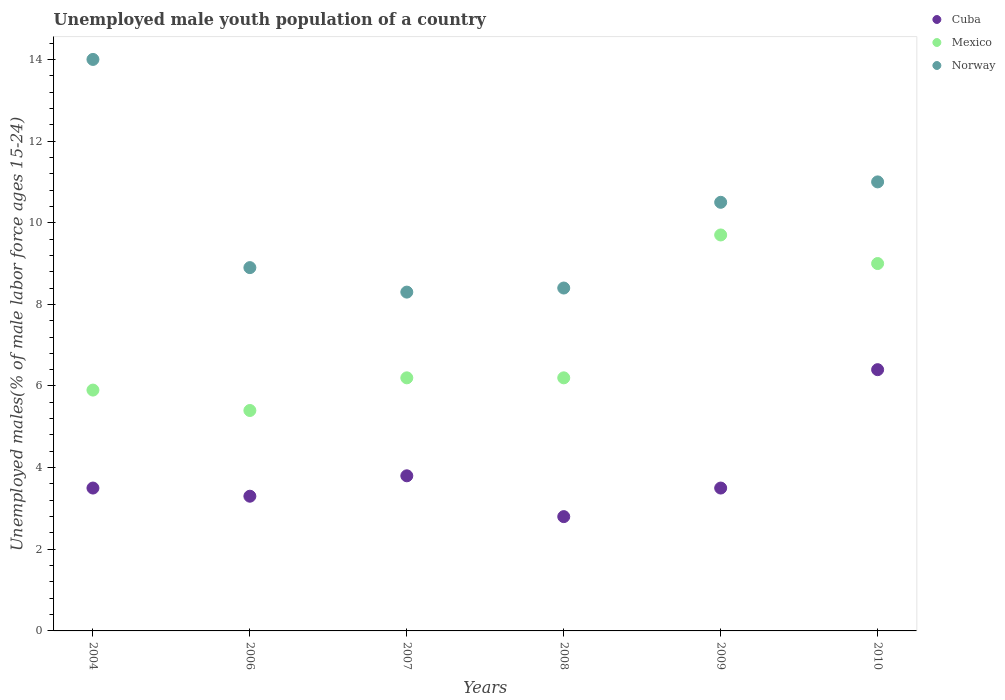How many different coloured dotlines are there?
Offer a terse response. 3. Is the number of dotlines equal to the number of legend labels?
Offer a terse response. Yes. What is the percentage of unemployed male youth population in Cuba in 2008?
Your answer should be compact. 2.8. Across all years, what is the maximum percentage of unemployed male youth population in Cuba?
Provide a short and direct response. 6.4. Across all years, what is the minimum percentage of unemployed male youth population in Norway?
Give a very brief answer. 8.3. In which year was the percentage of unemployed male youth population in Mexico maximum?
Provide a succinct answer. 2009. In which year was the percentage of unemployed male youth population in Cuba minimum?
Your answer should be compact. 2008. What is the total percentage of unemployed male youth population in Norway in the graph?
Provide a short and direct response. 61.1. What is the difference between the percentage of unemployed male youth population in Cuba in 2004 and the percentage of unemployed male youth population in Norway in 2007?
Your answer should be very brief. -4.8. What is the average percentage of unemployed male youth population in Norway per year?
Your answer should be very brief. 10.18. In the year 2007, what is the difference between the percentage of unemployed male youth population in Cuba and percentage of unemployed male youth population in Mexico?
Ensure brevity in your answer.  -2.4. What is the ratio of the percentage of unemployed male youth population in Mexico in 2006 to that in 2009?
Your answer should be compact. 0.56. Is the percentage of unemployed male youth population in Mexico in 2007 less than that in 2008?
Offer a very short reply. No. Is the difference between the percentage of unemployed male youth population in Cuba in 2004 and 2009 greater than the difference between the percentage of unemployed male youth population in Mexico in 2004 and 2009?
Your response must be concise. Yes. What is the difference between the highest and the second highest percentage of unemployed male youth population in Norway?
Provide a succinct answer. 3. What is the difference between the highest and the lowest percentage of unemployed male youth population in Mexico?
Give a very brief answer. 4.3. Is the sum of the percentage of unemployed male youth population in Mexico in 2006 and 2010 greater than the maximum percentage of unemployed male youth population in Cuba across all years?
Your answer should be very brief. Yes. Does the percentage of unemployed male youth population in Mexico monotonically increase over the years?
Keep it short and to the point. No. Is the percentage of unemployed male youth population in Mexico strictly greater than the percentage of unemployed male youth population in Norway over the years?
Provide a succinct answer. No. Is the percentage of unemployed male youth population in Cuba strictly less than the percentage of unemployed male youth population in Norway over the years?
Offer a terse response. Yes. How many dotlines are there?
Ensure brevity in your answer.  3. Are the values on the major ticks of Y-axis written in scientific E-notation?
Provide a short and direct response. No. Does the graph contain any zero values?
Give a very brief answer. No. Where does the legend appear in the graph?
Keep it short and to the point. Top right. How are the legend labels stacked?
Your answer should be compact. Vertical. What is the title of the graph?
Offer a very short reply. Unemployed male youth population of a country. What is the label or title of the X-axis?
Provide a succinct answer. Years. What is the label or title of the Y-axis?
Keep it short and to the point. Unemployed males(% of male labor force ages 15-24). What is the Unemployed males(% of male labor force ages 15-24) of Mexico in 2004?
Make the answer very short. 5.9. What is the Unemployed males(% of male labor force ages 15-24) of Cuba in 2006?
Offer a terse response. 3.3. What is the Unemployed males(% of male labor force ages 15-24) of Mexico in 2006?
Provide a short and direct response. 5.4. What is the Unemployed males(% of male labor force ages 15-24) of Norway in 2006?
Offer a very short reply. 8.9. What is the Unemployed males(% of male labor force ages 15-24) in Cuba in 2007?
Offer a terse response. 3.8. What is the Unemployed males(% of male labor force ages 15-24) of Mexico in 2007?
Offer a terse response. 6.2. What is the Unemployed males(% of male labor force ages 15-24) in Norway in 2007?
Provide a short and direct response. 8.3. What is the Unemployed males(% of male labor force ages 15-24) in Cuba in 2008?
Keep it short and to the point. 2.8. What is the Unemployed males(% of male labor force ages 15-24) of Mexico in 2008?
Offer a very short reply. 6.2. What is the Unemployed males(% of male labor force ages 15-24) of Norway in 2008?
Your answer should be very brief. 8.4. What is the Unemployed males(% of male labor force ages 15-24) in Cuba in 2009?
Make the answer very short. 3.5. What is the Unemployed males(% of male labor force ages 15-24) of Mexico in 2009?
Offer a very short reply. 9.7. What is the Unemployed males(% of male labor force ages 15-24) in Cuba in 2010?
Keep it short and to the point. 6.4. What is the Unemployed males(% of male labor force ages 15-24) of Mexico in 2010?
Give a very brief answer. 9. What is the Unemployed males(% of male labor force ages 15-24) of Norway in 2010?
Offer a very short reply. 11. Across all years, what is the maximum Unemployed males(% of male labor force ages 15-24) of Cuba?
Make the answer very short. 6.4. Across all years, what is the maximum Unemployed males(% of male labor force ages 15-24) of Mexico?
Ensure brevity in your answer.  9.7. Across all years, what is the maximum Unemployed males(% of male labor force ages 15-24) of Norway?
Give a very brief answer. 14. Across all years, what is the minimum Unemployed males(% of male labor force ages 15-24) in Cuba?
Your answer should be compact. 2.8. Across all years, what is the minimum Unemployed males(% of male labor force ages 15-24) in Mexico?
Your answer should be very brief. 5.4. Across all years, what is the minimum Unemployed males(% of male labor force ages 15-24) of Norway?
Your answer should be compact. 8.3. What is the total Unemployed males(% of male labor force ages 15-24) in Cuba in the graph?
Your answer should be compact. 23.3. What is the total Unemployed males(% of male labor force ages 15-24) in Mexico in the graph?
Your response must be concise. 42.4. What is the total Unemployed males(% of male labor force ages 15-24) in Norway in the graph?
Your answer should be compact. 61.1. What is the difference between the Unemployed males(% of male labor force ages 15-24) in Cuba in 2004 and that in 2006?
Offer a very short reply. 0.2. What is the difference between the Unemployed males(% of male labor force ages 15-24) of Mexico in 2004 and that in 2006?
Your response must be concise. 0.5. What is the difference between the Unemployed males(% of male labor force ages 15-24) in Cuba in 2004 and that in 2007?
Ensure brevity in your answer.  -0.3. What is the difference between the Unemployed males(% of male labor force ages 15-24) of Norway in 2004 and that in 2007?
Give a very brief answer. 5.7. What is the difference between the Unemployed males(% of male labor force ages 15-24) of Cuba in 2004 and that in 2008?
Offer a very short reply. 0.7. What is the difference between the Unemployed males(% of male labor force ages 15-24) of Mexico in 2004 and that in 2008?
Give a very brief answer. -0.3. What is the difference between the Unemployed males(% of male labor force ages 15-24) of Norway in 2004 and that in 2008?
Your answer should be very brief. 5.6. What is the difference between the Unemployed males(% of male labor force ages 15-24) of Cuba in 2004 and that in 2009?
Offer a very short reply. 0. What is the difference between the Unemployed males(% of male labor force ages 15-24) of Mexico in 2004 and that in 2009?
Your answer should be compact. -3.8. What is the difference between the Unemployed males(% of male labor force ages 15-24) of Norway in 2004 and that in 2009?
Ensure brevity in your answer.  3.5. What is the difference between the Unemployed males(% of male labor force ages 15-24) in Cuba in 2004 and that in 2010?
Provide a succinct answer. -2.9. What is the difference between the Unemployed males(% of male labor force ages 15-24) in Norway in 2004 and that in 2010?
Offer a very short reply. 3. What is the difference between the Unemployed males(% of male labor force ages 15-24) of Cuba in 2006 and that in 2007?
Your answer should be very brief. -0.5. What is the difference between the Unemployed males(% of male labor force ages 15-24) in Mexico in 2006 and that in 2007?
Offer a very short reply. -0.8. What is the difference between the Unemployed males(% of male labor force ages 15-24) of Norway in 2006 and that in 2007?
Keep it short and to the point. 0.6. What is the difference between the Unemployed males(% of male labor force ages 15-24) in Cuba in 2006 and that in 2008?
Give a very brief answer. 0.5. What is the difference between the Unemployed males(% of male labor force ages 15-24) of Mexico in 2006 and that in 2008?
Your answer should be compact. -0.8. What is the difference between the Unemployed males(% of male labor force ages 15-24) in Mexico in 2006 and that in 2010?
Provide a short and direct response. -3.6. What is the difference between the Unemployed males(% of male labor force ages 15-24) of Mexico in 2007 and that in 2008?
Your answer should be compact. 0. What is the difference between the Unemployed males(% of male labor force ages 15-24) in Cuba in 2007 and that in 2009?
Ensure brevity in your answer.  0.3. What is the difference between the Unemployed males(% of male labor force ages 15-24) of Norway in 2007 and that in 2009?
Offer a terse response. -2.2. What is the difference between the Unemployed males(% of male labor force ages 15-24) in Mexico in 2007 and that in 2010?
Keep it short and to the point. -2.8. What is the difference between the Unemployed males(% of male labor force ages 15-24) in Cuba in 2008 and that in 2009?
Offer a very short reply. -0.7. What is the difference between the Unemployed males(% of male labor force ages 15-24) of Mexico in 2008 and that in 2009?
Offer a very short reply. -3.5. What is the difference between the Unemployed males(% of male labor force ages 15-24) in Cuba in 2009 and that in 2010?
Offer a terse response. -2.9. What is the difference between the Unemployed males(% of male labor force ages 15-24) in Cuba in 2004 and the Unemployed males(% of male labor force ages 15-24) in Mexico in 2006?
Give a very brief answer. -1.9. What is the difference between the Unemployed males(% of male labor force ages 15-24) in Cuba in 2004 and the Unemployed males(% of male labor force ages 15-24) in Norway in 2006?
Your answer should be very brief. -5.4. What is the difference between the Unemployed males(% of male labor force ages 15-24) in Cuba in 2004 and the Unemployed males(% of male labor force ages 15-24) in Norway in 2007?
Keep it short and to the point. -4.8. What is the difference between the Unemployed males(% of male labor force ages 15-24) in Cuba in 2004 and the Unemployed males(% of male labor force ages 15-24) in Mexico in 2008?
Give a very brief answer. -2.7. What is the difference between the Unemployed males(% of male labor force ages 15-24) in Cuba in 2004 and the Unemployed males(% of male labor force ages 15-24) in Norway in 2008?
Offer a very short reply. -4.9. What is the difference between the Unemployed males(% of male labor force ages 15-24) in Mexico in 2004 and the Unemployed males(% of male labor force ages 15-24) in Norway in 2008?
Make the answer very short. -2.5. What is the difference between the Unemployed males(% of male labor force ages 15-24) of Cuba in 2004 and the Unemployed males(% of male labor force ages 15-24) of Mexico in 2009?
Your answer should be very brief. -6.2. What is the difference between the Unemployed males(% of male labor force ages 15-24) in Cuba in 2004 and the Unemployed males(% of male labor force ages 15-24) in Norway in 2009?
Offer a terse response. -7. What is the difference between the Unemployed males(% of male labor force ages 15-24) of Cuba in 2004 and the Unemployed males(% of male labor force ages 15-24) of Norway in 2010?
Ensure brevity in your answer.  -7.5. What is the difference between the Unemployed males(% of male labor force ages 15-24) in Cuba in 2006 and the Unemployed males(% of male labor force ages 15-24) in Mexico in 2007?
Your answer should be very brief. -2.9. What is the difference between the Unemployed males(% of male labor force ages 15-24) of Cuba in 2006 and the Unemployed males(% of male labor force ages 15-24) of Mexico in 2009?
Your response must be concise. -6.4. What is the difference between the Unemployed males(% of male labor force ages 15-24) of Mexico in 2006 and the Unemployed males(% of male labor force ages 15-24) of Norway in 2009?
Offer a very short reply. -5.1. What is the difference between the Unemployed males(% of male labor force ages 15-24) of Cuba in 2006 and the Unemployed males(% of male labor force ages 15-24) of Norway in 2010?
Keep it short and to the point. -7.7. What is the difference between the Unemployed males(% of male labor force ages 15-24) in Cuba in 2007 and the Unemployed males(% of male labor force ages 15-24) in Norway in 2008?
Give a very brief answer. -4.6. What is the difference between the Unemployed males(% of male labor force ages 15-24) in Mexico in 2007 and the Unemployed males(% of male labor force ages 15-24) in Norway in 2008?
Provide a succinct answer. -2.2. What is the difference between the Unemployed males(% of male labor force ages 15-24) in Cuba in 2007 and the Unemployed males(% of male labor force ages 15-24) in Norway in 2009?
Your response must be concise. -6.7. What is the difference between the Unemployed males(% of male labor force ages 15-24) of Mexico in 2007 and the Unemployed males(% of male labor force ages 15-24) of Norway in 2009?
Make the answer very short. -4.3. What is the difference between the Unemployed males(% of male labor force ages 15-24) of Cuba in 2008 and the Unemployed males(% of male labor force ages 15-24) of Mexico in 2009?
Provide a succinct answer. -6.9. What is the difference between the Unemployed males(% of male labor force ages 15-24) of Cuba in 2008 and the Unemployed males(% of male labor force ages 15-24) of Norway in 2009?
Ensure brevity in your answer.  -7.7. What is the difference between the Unemployed males(% of male labor force ages 15-24) in Cuba in 2008 and the Unemployed males(% of male labor force ages 15-24) in Mexico in 2010?
Your answer should be very brief. -6.2. What is the difference between the Unemployed males(% of male labor force ages 15-24) in Cuba in 2008 and the Unemployed males(% of male labor force ages 15-24) in Norway in 2010?
Provide a succinct answer. -8.2. What is the difference between the Unemployed males(% of male labor force ages 15-24) of Mexico in 2008 and the Unemployed males(% of male labor force ages 15-24) of Norway in 2010?
Keep it short and to the point. -4.8. What is the difference between the Unemployed males(% of male labor force ages 15-24) of Cuba in 2009 and the Unemployed males(% of male labor force ages 15-24) of Norway in 2010?
Offer a very short reply. -7.5. What is the average Unemployed males(% of male labor force ages 15-24) in Cuba per year?
Your answer should be compact. 3.88. What is the average Unemployed males(% of male labor force ages 15-24) in Mexico per year?
Keep it short and to the point. 7.07. What is the average Unemployed males(% of male labor force ages 15-24) of Norway per year?
Offer a very short reply. 10.18. In the year 2004, what is the difference between the Unemployed males(% of male labor force ages 15-24) in Cuba and Unemployed males(% of male labor force ages 15-24) in Mexico?
Your response must be concise. -2.4. In the year 2006, what is the difference between the Unemployed males(% of male labor force ages 15-24) of Cuba and Unemployed males(% of male labor force ages 15-24) of Norway?
Your response must be concise. -5.6. In the year 2007, what is the difference between the Unemployed males(% of male labor force ages 15-24) in Cuba and Unemployed males(% of male labor force ages 15-24) in Mexico?
Provide a succinct answer. -2.4. In the year 2007, what is the difference between the Unemployed males(% of male labor force ages 15-24) of Cuba and Unemployed males(% of male labor force ages 15-24) of Norway?
Ensure brevity in your answer.  -4.5. In the year 2007, what is the difference between the Unemployed males(% of male labor force ages 15-24) of Mexico and Unemployed males(% of male labor force ages 15-24) of Norway?
Give a very brief answer. -2.1. In the year 2008, what is the difference between the Unemployed males(% of male labor force ages 15-24) of Cuba and Unemployed males(% of male labor force ages 15-24) of Mexico?
Your answer should be very brief. -3.4. In the year 2008, what is the difference between the Unemployed males(% of male labor force ages 15-24) of Mexico and Unemployed males(% of male labor force ages 15-24) of Norway?
Your answer should be compact. -2.2. In the year 2009, what is the difference between the Unemployed males(% of male labor force ages 15-24) of Cuba and Unemployed males(% of male labor force ages 15-24) of Mexico?
Keep it short and to the point. -6.2. In the year 2009, what is the difference between the Unemployed males(% of male labor force ages 15-24) of Mexico and Unemployed males(% of male labor force ages 15-24) of Norway?
Ensure brevity in your answer.  -0.8. In the year 2010, what is the difference between the Unemployed males(% of male labor force ages 15-24) of Cuba and Unemployed males(% of male labor force ages 15-24) of Mexico?
Ensure brevity in your answer.  -2.6. In the year 2010, what is the difference between the Unemployed males(% of male labor force ages 15-24) of Mexico and Unemployed males(% of male labor force ages 15-24) of Norway?
Make the answer very short. -2. What is the ratio of the Unemployed males(% of male labor force ages 15-24) of Cuba in 2004 to that in 2006?
Your answer should be compact. 1.06. What is the ratio of the Unemployed males(% of male labor force ages 15-24) in Mexico in 2004 to that in 2006?
Ensure brevity in your answer.  1.09. What is the ratio of the Unemployed males(% of male labor force ages 15-24) in Norway in 2004 to that in 2006?
Provide a short and direct response. 1.57. What is the ratio of the Unemployed males(% of male labor force ages 15-24) in Cuba in 2004 to that in 2007?
Your answer should be compact. 0.92. What is the ratio of the Unemployed males(% of male labor force ages 15-24) of Mexico in 2004 to that in 2007?
Offer a very short reply. 0.95. What is the ratio of the Unemployed males(% of male labor force ages 15-24) of Norway in 2004 to that in 2007?
Provide a succinct answer. 1.69. What is the ratio of the Unemployed males(% of male labor force ages 15-24) of Mexico in 2004 to that in 2008?
Provide a succinct answer. 0.95. What is the ratio of the Unemployed males(% of male labor force ages 15-24) in Cuba in 2004 to that in 2009?
Ensure brevity in your answer.  1. What is the ratio of the Unemployed males(% of male labor force ages 15-24) of Mexico in 2004 to that in 2009?
Make the answer very short. 0.61. What is the ratio of the Unemployed males(% of male labor force ages 15-24) in Norway in 2004 to that in 2009?
Provide a succinct answer. 1.33. What is the ratio of the Unemployed males(% of male labor force ages 15-24) in Cuba in 2004 to that in 2010?
Your answer should be very brief. 0.55. What is the ratio of the Unemployed males(% of male labor force ages 15-24) in Mexico in 2004 to that in 2010?
Your answer should be very brief. 0.66. What is the ratio of the Unemployed males(% of male labor force ages 15-24) of Norway in 2004 to that in 2010?
Provide a succinct answer. 1.27. What is the ratio of the Unemployed males(% of male labor force ages 15-24) of Cuba in 2006 to that in 2007?
Give a very brief answer. 0.87. What is the ratio of the Unemployed males(% of male labor force ages 15-24) in Mexico in 2006 to that in 2007?
Provide a short and direct response. 0.87. What is the ratio of the Unemployed males(% of male labor force ages 15-24) in Norway in 2006 to that in 2007?
Offer a terse response. 1.07. What is the ratio of the Unemployed males(% of male labor force ages 15-24) of Cuba in 2006 to that in 2008?
Your answer should be compact. 1.18. What is the ratio of the Unemployed males(% of male labor force ages 15-24) of Mexico in 2006 to that in 2008?
Keep it short and to the point. 0.87. What is the ratio of the Unemployed males(% of male labor force ages 15-24) in Norway in 2006 to that in 2008?
Ensure brevity in your answer.  1.06. What is the ratio of the Unemployed males(% of male labor force ages 15-24) of Cuba in 2006 to that in 2009?
Your answer should be very brief. 0.94. What is the ratio of the Unemployed males(% of male labor force ages 15-24) of Mexico in 2006 to that in 2009?
Your answer should be very brief. 0.56. What is the ratio of the Unemployed males(% of male labor force ages 15-24) in Norway in 2006 to that in 2009?
Your response must be concise. 0.85. What is the ratio of the Unemployed males(% of male labor force ages 15-24) in Cuba in 2006 to that in 2010?
Provide a succinct answer. 0.52. What is the ratio of the Unemployed males(% of male labor force ages 15-24) in Mexico in 2006 to that in 2010?
Provide a succinct answer. 0.6. What is the ratio of the Unemployed males(% of male labor force ages 15-24) in Norway in 2006 to that in 2010?
Keep it short and to the point. 0.81. What is the ratio of the Unemployed males(% of male labor force ages 15-24) of Cuba in 2007 to that in 2008?
Keep it short and to the point. 1.36. What is the ratio of the Unemployed males(% of male labor force ages 15-24) of Cuba in 2007 to that in 2009?
Your response must be concise. 1.09. What is the ratio of the Unemployed males(% of male labor force ages 15-24) in Mexico in 2007 to that in 2009?
Make the answer very short. 0.64. What is the ratio of the Unemployed males(% of male labor force ages 15-24) in Norway in 2007 to that in 2009?
Offer a very short reply. 0.79. What is the ratio of the Unemployed males(% of male labor force ages 15-24) in Cuba in 2007 to that in 2010?
Ensure brevity in your answer.  0.59. What is the ratio of the Unemployed males(% of male labor force ages 15-24) in Mexico in 2007 to that in 2010?
Offer a terse response. 0.69. What is the ratio of the Unemployed males(% of male labor force ages 15-24) in Norway in 2007 to that in 2010?
Give a very brief answer. 0.75. What is the ratio of the Unemployed males(% of male labor force ages 15-24) of Mexico in 2008 to that in 2009?
Ensure brevity in your answer.  0.64. What is the ratio of the Unemployed males(% of male labor force ages 15-24) in Cuba in 2008 to that in 2010?
Your answer should be very brief. 0.44. What is the ratio of the Unemployed males(% of male labor force ages 15-24) of Mexico in 2008 to that in 2010?
Offer a very short reply. 0.69. What is the ratio of the Unemployed males(% of male labor force ages 15-24) in Norway in 2008 to that in 2010?
Keep it short and to the point. 0.76. What is the ratio of the Unemployed males(% of male labor force ages 15-24) of Cuba in 2009 to that in 2010?
Your answer should be compact. 0.55. What is the ratio of the Unemployed males(% of male labor force ages 15-24) in Mexico in 2009 to that in 2010?
Provide a succinct answer. 1.08. What is the ratio of the Unemployed males(% of male labor force ages 15-24) of Norway in 2009 to that in 2010?
Give a very brief answer. 0.95. What is the difference between the highest and the second highest Unemployed males(% of male labor force ages 15-24) of Mexico?
Your response must be concise. 0.7. What is the difference between the highest and the lowest Unemployed males(% of male labor force ages 15-24) in Mexico?
Keep it short and to the point. 4.3. What is the difference between the highest and the lowest Unemployed males(% of male labor force ages 15-24) in Norway?
Offer a very short reply. 5.7. 